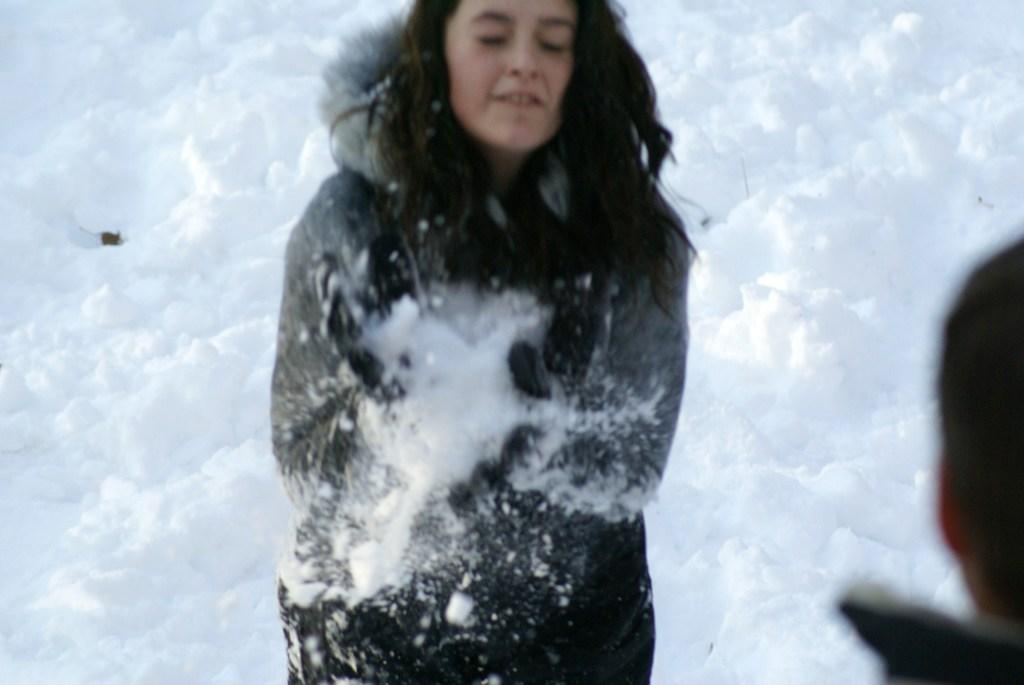What is the primary subject in the image? There is a person standing in the image. What is the weather or environment like in the image? There is snow visible in the image. What type of bait is the person using to catch fish in the image? There is no indication of fishing or bait in the image, as it only features a person standing in the snow. 